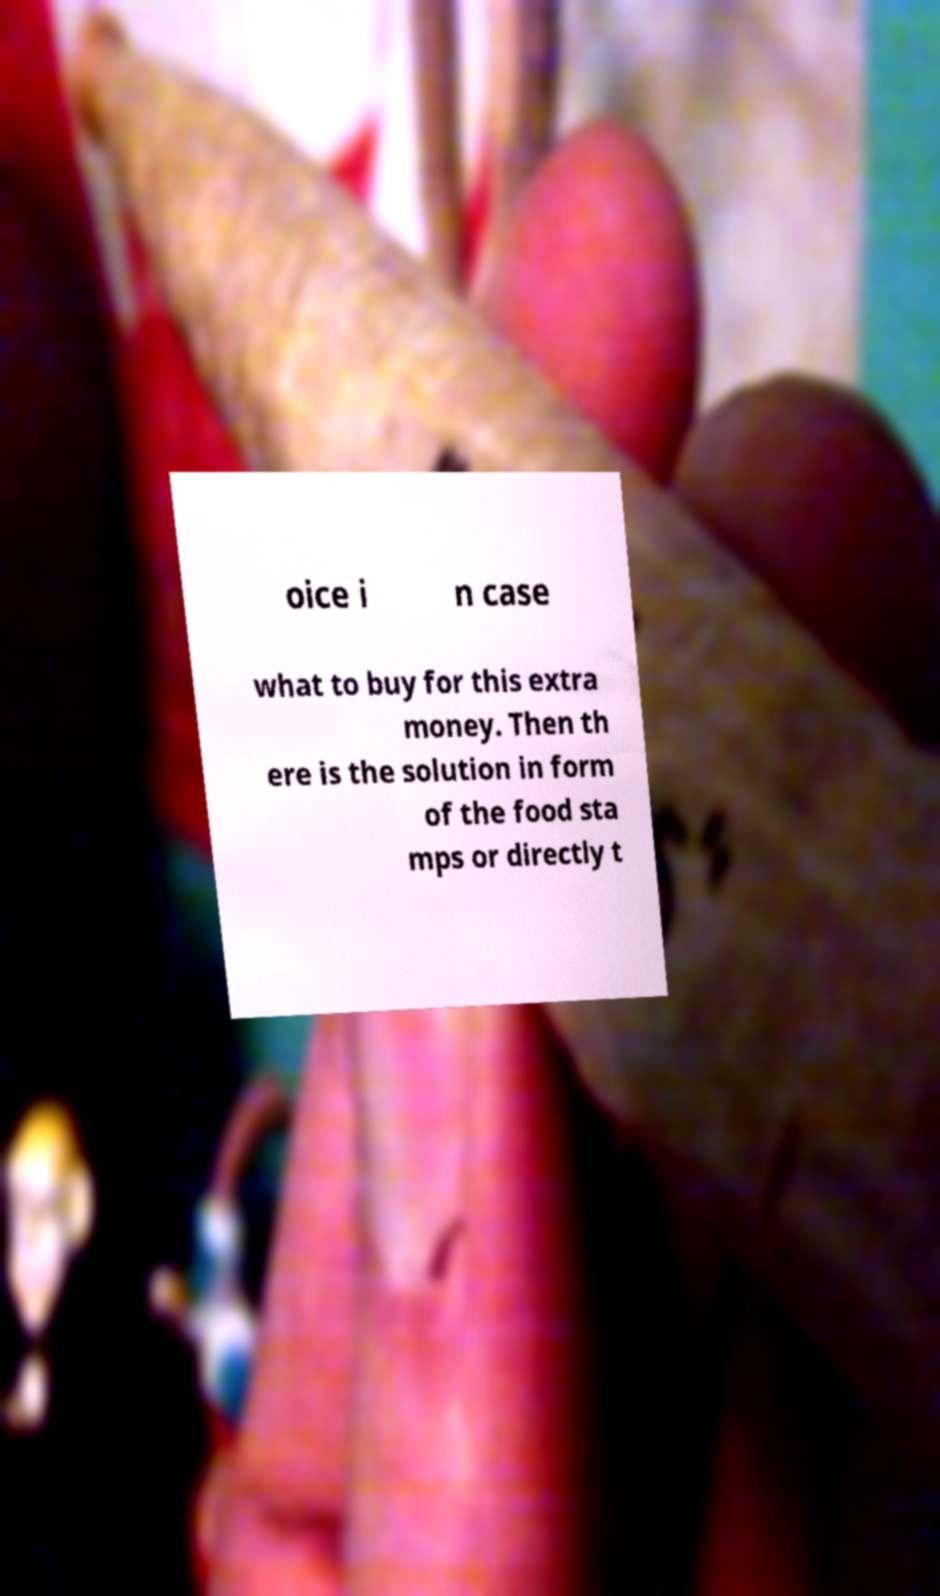Please identify and transcribe the text found in this image. oice i n case what to buy for this extra money. Then th ere is the solution in form of the food sta mps or directly t 